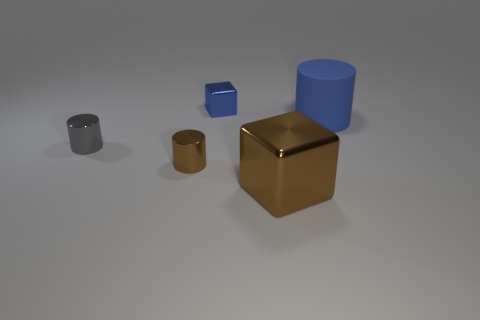Subtract all shiny cylinders. How many cylinders are left? 1 Add 2 green objects. How many objects exist? 7 Subtract all cubes. How many objects are left? 3 Subtract all gray cylinders. Subtract all blue balls. How many cylinders are left? 2 Subtract all big green matte balls. Subtract all small metallic blocks. How many objects are left? 4 Add 5 small metal cylinders. How many small metal cylinders are left? 7 Add 3 tiny cyan cubes. How many tiny cyan cubes exist? 3 Subtract all gray cylinders. How many cylinders are left? 2 Subtract 0 brown spheres. How many objects are left? 5 